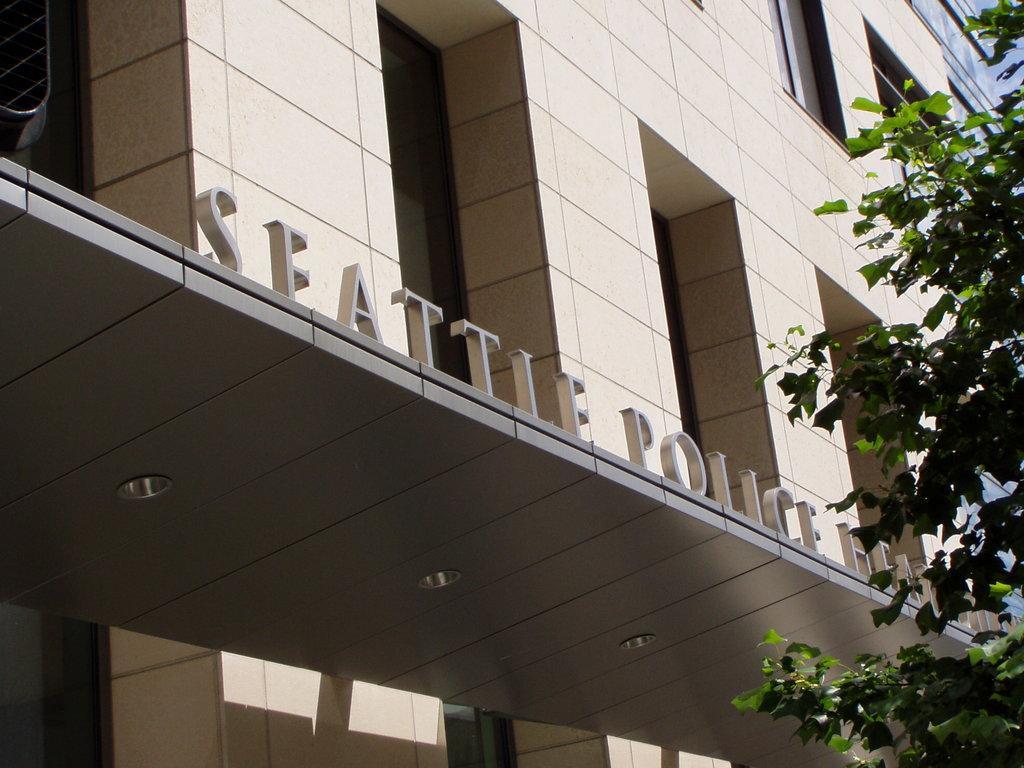Describe this image in one or two sentences. In the foreground of this image, on the right, there is a tree. In the background, there is a building, a name on it and few lights to it. 